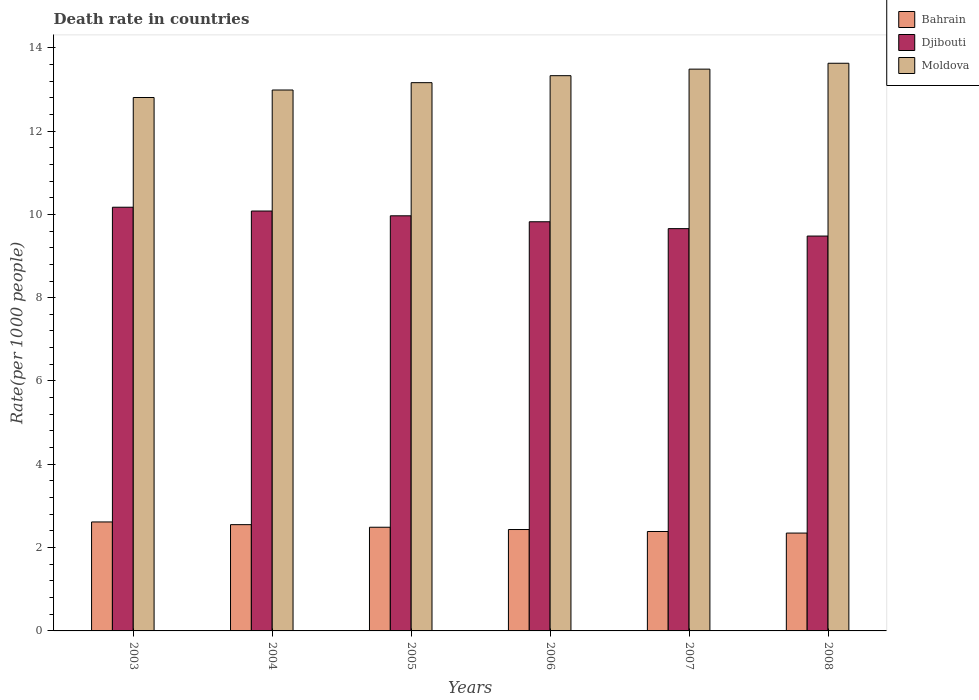How many different coloured bars are there?
Give a very brief answer. 3. How many groups of bars are there?
Offer a terse response. 6. Are the number of bars per tick equal to the number of legend labels?
Provide a succinct answer. Yes. How many bars are there on the 1st tick from the left?
Offer a very short reply. 3. What is the death rate in Moldova in 2003?
Your answer should be compact. 12.8. Across all years, what is the maximum death rate in Bahrain?
Provide a succinct answer. 2.62. Across all years, what is the minimum death rate in Moldova?
Provide a short and direct response. 12.8. In which year was the death rate in Moldova minimum?
Ensure brevity in your answer.  2003. What is the total death rate in Moldova in the graph?
Your answer should be compact. 79.39. What is the difference between the death rate in Djibouti in 2007 and that in 2008?
Offer a terse response. 0.18. What is the difference between the death rate in Moldova in 2008 and the death rate in Bahrain in 2004?
Offer a very short reply. 11.08. What is the average death rate in Moldova per year?
Provide a short and direct response. 13.23. In the year 2003, what is the difference between the death rate in Moldova and death rate in Djibouti?
Offer a very short reply. 2.63. In how many years, is the death rate in Bahrain greater than 10.4?
Provide a short and direct response. 0. What is the ratio of the death rate in Moldova in 2007 to that in 2008?
Give a very brief answer. 0.99. Is the death rate in Moldova in 2006 less than that in 2008?
Give a very brief answer. Yes. What is the difference between the highest and the second highest death rate in Djibouti?
Offer a very short reply. 0.09. What is the difference between the highest and the lowest death rate in Moldova?
Offer a very short reply. 0.82. In how many years, is the death rate in Djibouti greater than the average death rate in Djibouti taken over all years?
Give a very brief answer. 3. Is the sum of the death rate in Djibouti in 2007 and 2008 greater than the maximum death rate in Bahrain across all years?
Your answer should be very brief. Yes. What does the 3rd bar from the left in 2004 represents?
Offer a very short reply. Moldova. What does the 2nd bar from the right in 2007 represents?
Offer a terse response. Djibouti. Is it the case that in every year, the sum of the death rate in Moldova and death rate in Djibouti is greater than the death rate in Bahrain?
Make the answer very short. Yes. How many bars are there?
Make the answer very short. 18. How many years are there in the graph?
Provide a short and direct response. 6. What is the difference between two consecutive major ticks on the Y-axis?
Your answer should be very brief. 2. Are the values on the major ticks of Y-axis written in scientific E-notation?
Give a very brief answer. No. Where does the legend appear in the graph?
Make the answer very short. Top right. How are the legend labels stacked?
Ensure brevity in your answer.  Vertical. What is the title of the graph?
Offer a very short reply. Death rate in countries. What is the label or title of the X-axis?
Offer a terse response. Years. What is the label or title of the Y-axis?
Keep it short and to the point. Rate(per 1000 people). What is the Rate(per 1000 people) of Bahrain in 2003?
Your response must be concise. 2.62. What is the Rate(per 1000 people) of Djibouti in 2003?
Your answer should be very brief. 10.17. What is the Rate(per 1000 people) of Moldova in 2003?
Ensure brevity in your answer.  12.8. What is the Rate(per 1000 people) of Bahrain in 2004?
Your answer should be very brief. 2.55. What is the Rate(per 1000 people) in Djibouti in 2004?
Make the answer very short. 10.08. What is the Rate(per 1000 people) in Moldova in 2004?
Your response must be concise. 12.98. What is the Rate(per 1000 people) of Bahrain in 2005?
Offer a terse response. 2.49. What is the Rate(per 1000 people) of Djibouti in 2005?
Your answer should be very brief. 9.96. What is the Rate(per 1000 people) of Moldova in 2005?
Ensure brevity in your answer.  13.16. What is the Rate(per 1000 people) of Bahrain in 2006?
Ensure brevity in your answer.  2.43. What is the Rate(per 1000 people) of Djibouti in 2006?
Make the answer very short. 9.82. What is the Rate(per 1000 people) in Moldova in 2006?
Provide a short and direct response. 13.33. What is the Rate(per 1000 people) in Bahrain in 2007?
Your answer should be very brief. 2.39. What is the Rate(per 1000 people) in Djibouti in 2007?
Provide a short and direct response. 9.66. What is the Rate(per 1000 people) in Moldova in 2007?
Provide a short and direct response. 13.49. What is the Rate(per 1000 people) in Bahrain in 2008?
Your response must be concise. 2.35. What is the Rate(per 1000 people) of Djibouti in 2008?
Provide a short and direct response. 9.48. What is the Rate(per 1000 people) of Moldova in 2008?
Offer a very short reply. 13.63. Across all years, what is the maximum Rate(per 1000 people) of Bahrain?
Your answer should be very brief. 2.62. Across all years, what is the maximum Rate(per 1000 people) in Djibouti?
Your answer should be very brief. 10.17. Across all years, what is the maximum Rate(per 1000 people) of Moldova?
Provide a short and direct response. 13.63. Across all years, what is the minimum Rate(per 1000 people) of Bahrain?
Offer a terse response. 2.35. Across all years, what is the minimum Rate(per 1000 people) in Djibouti?
Your response must be concise. 9.48. Across all years, what is the minimum Rate(per 1000 people) in Moldova?
Provide a succinct answer. 12.8. What is the total Rate(per 1000 people) of Bahrain in the graph?
Give a very brief answer. 14.83. What is the total Rate(per 1000 people) of Djibouti in the graph?
Keep it short and to the point. 59.17. What is the total Rate(per 1000 people) in Moldova in the graph?
Provide a succinct answer. 79.39. What is the difference between the Rate(per 1000 people) in Bahrain in 2003 and that in 2004?
Your answer should be very brief. 0.07. What is the difference between the Rate(per 1000 people) of Djibouti in 2003 and that in 2004?
Your answer should be very brief. 0.09. What is the difference between the Rate(per 1000 people) in Moldova in 2003 and that in 2004?
Your answer should be compact. -0.18. What is the difference between the Rate(per 1000 people) of Bahrain in 2003 and that in 2005?
Ensure brevity in your answer.  0.13. What is the difference between the Rate(per 1000 people) in Djibouti in 2003 and that in 2005?
Provide a short and direct response. 0.21. What is the difference between the Rate(per 1000 people) of Moldova in 2003 and that in 2005?
Keep it short and to the point. -0.36. What is the difference between the Rate(per 1000 people) of Bahrain in 2003 and that in 2006?
Make the answer very short. 0.18. What is the difference between the Rate(per 1000 people) of Djibouti in 2003 and that in 2006?
Make the answer very short. 0.35. What is the difference between the Rate(per 1000 people) in Moldova in 2003 and that in 2006?
Your response must be concise. -0.52. What is the difference between the Rate(per 1000 people) of Bahrain in 2003 and that in 2007?
Provide a short and direct response. 0.23. What is the difference between the Rate(per 1000 people) of Djibouti in 2003 and that in 2007?
Ensure brevity in your answer.  0.51. What is the difference between the Rate(per 1000 people) in Moldova in 2003 and that in 2007?
Offer a terse response. -0.68. What is the difference between the Rate(per 1000 people) in Bahrain in 2003 and that in 2008?
Your response must be concise. 0.27. What is the difference between the Rate(per 1000 people) in Djibouti in 2003 and that in 2008?
Make the answer very short. 0.69. What is the difference between the Rate(per 1000 people) of Moldova in 2003 and that in 2008?
Your answer should be very brief. -0.82. What is the difference between the Rate(per 1000 people) in Bahrain in 2004 and that in 2005?
Your response must be concise. 0.06. What is the difference between the Rate(per 1000 people) in Djibouti in 2004 and that in 2005?
Keep it short and to the point. 0.12. What is the difference between the Rate(per 1000 people) of Moldova in 2004 and that in 2005?
Give a very brief answer. -0.18. What is the difference between the Rate(per 1000 people) of Bahrain in 2004 and that in 2006?
Ensure brevity in your answer.  0.12. What is the difference between the Rate(per 1000 people) in Djibouti in 2004 and that in 2006?
Ensure brevity in your answer.  0.26. What is the difference between the Rate(per 1000 people) of Moldova in 2004 and that in 2006?
Ensure brevity in your answer.  -0.34. What is the difference between the Rate(per 1000 people) in Bahrain in 2004 and that in 2007?
Offer a terse response. 0.16. What is the difference between the Rate(per 1000 people) in Djibouti in 2004 and that in 2007?
Your answer should be very brief. 0.42. What is the difference between the Rate(per 1000 people) in Moldova in 2004 and that in 2007?
Ensure brevity in your answer.  -0.5. What is the difference between the Rate(per 1000 people) of Bahrain in 2004 and that in 2008?
Your response must be concise. 0.2. What is the difference between the Rate(per 1000 people) of Djibouti in 2004 and that in 2008?
Your answer should be very brief. 0.6. What is the difference between the Rate(per 1000 people) in Moldova in 2004 and that in 2008?
Give a very brief answer. -0.64. What is the difference between the Rate(per 1000 people) of Bahrain in 2005 and that in 2006?
Offer a terse response. 0.06. What is the difference between the Rate(per 1000 people) of Djibouti in 2005 and that in 2006?
Offer a terse response. 0.14. What is the difference between the Rate(per 1000 people) of Moldova in 2005 and that in 2006?
Ensure brevity in your answer.  -0.17. What is the difference between the Rate(per 1000 people) of Bahrain in 2005 and that in 2007?
Provide a succinct answer. 0.1. What is the difference between the Rate(per 1000 people) of Djibouti in 2005 and that in 2007?
Your response must be concise. 0.31. What is the difference between the Rate(per 1000 people) in Moldova in 2005 and that in 2007?
Offer a very short reply. -0.33. What is the difference between the Rate(per 1000 people) of Bahrain in 2005 and that in 2008?
Give a very brief answer. 0.14. What is the difference between the Rate(per 1000 people) of Djibouti in 2005 and that in 2008?
Give a very brief answer. 0.49. What is the difference between the Rate(per 1000 people) in Moldova in 2005 and that in 2008?
Your answer should be compact. -0.47. What is the difference between the Rate(per 1000 people) in Bahrain in 2006 and that in 2007?
Your answer should be very brief. 0.05. What is the difference between the Rate(per 1000 people) in Djibouti in 2006 and that in 2007?
Your answer should be very brief. 0.17. What is the difference between the Rate(per 1000 people) in Moldova in 2006 and that in 2007?
Give a very brief answer. -0.16. What is the difference between the Rate(per 1000 people) of Bahrain in 2006 and that in 2008?
Offer a terse response. 0.09. What is the difference between the Rate(per 1000 people) of Djibouti in 2006 and that in 2008?
Give a very brief answer. 0.34. What is the difference between the Rate(per 1000 people) in Moldova in 2006 and that in 2008?
Your answer should be very brief. -0.3. What is the difference between the Rate(per 1000 people) in Bahrain in 2007 and that in 2008?
Keep it short and to the point. 0.04. What is the difference between the Rate(per 1000 people) in Djibouti in 2007 and that in 2008?
Ensure brevity in your answer.  0.18. What is the difference between the Rate(per 1000 people) in Moldova in 2007 and that in 2008?
Make the answer very short. -0.14. What is the difference between the Rate(per 1000 people) in Bahrain in 2003 and the Rate(per 1000 people) in Djibouti in 2004?
Ensure brevity in your answer.  -7.46. What is the difference between the Rate(per 1000 people) of Bahrain in 2003 and the Rate(per 1000 people) of Moldova in 2004?
Your answer should be compact. -10.37. What is the difference between the Rate(per 1000 people) of Djibouti in 2003 and the Rate(per 1000 people) of Moldova in 2004?
Your answer should be compact. -2.81. What is the difference between the Rate(per 1000 people) of Bahrain in 2003 and the Rate(per 1000 people) of Djibouti in 2005?
Your response must be concise. -7.35. What is the difference between the Rate(per 1000 people) of Bahrain in 2003 and the Rate(per 1000 people) of Moldova in 2005?
Offer a very short reply. -10.54. What is the difference between the Rate(per 1000 people) of Djibouti in 2003 and the Rate(per 1000 people) of Moldova in 2005?
Ensure brevity in your answer.  -2.99. What is the difference between the Rate(per 1000 people) in Bahrain in 2003 and the Rate(per 1000 people) in Djibouti in 2006?
Provide a succinct answer. -7.21. What is the difference between the Rate(per 1000 people) of Bahrain in 2003 and the Rate(per 1000 people) of Moldova in 2006?
Provide a short and direct response. -10.71. What is the difference between the Rate(per 1000 people) of Djibouti in 2003 and the Rate(per 1000 people) of Moldova in 2006?
Make the answer very short. -3.16. What is the difference between the Rate(per 1000 people) of Bahrain in 2003 and the Rate(per 1000 people) of Djibouti in 2007?
Your answer should be compact. -7.04. What is the difference between the Rate(per 1000 people) in Bahrain in 2003 and the Rate(per 1000 people) in Moldova in 2007?
Your response must be concise. -10.87. What is the difference between the Rate(per 1000 people) of Djibouti in 2003 and the Rate(per 1000 people) of Moldova in 2007?
Keep it short and to the point. -3.31. What is the difference between the Rate(per 1000 people) in Bahrain in 2003 and the Rate(per 1000 people) in Djibouti in 2008?
Your answer should be compact. -6.86. What is the difference between the Rate(per 1000 people) of Bahrain in 2003 and the Rate(per 1000 people) of Moldova in 2008?
Ensure brevity in your answer.  -11.01. What is the difference between the Rate(per 1000 people) of Djibouti in 2003 and the Rate(per 1000 people) of Moldova in 2008?
Keep it short and to the point. -3.46. What is the difference between the Rate(per 1000 people) of Bahrain in 2004 and the Rate(per 1000 people) of Djibouti in 2005?
Offer a very short reply. -7.41. What is the difference between the Rate(per 1000 people) in Bahrain in 2004 and the Rate(per 1000 people) in Moldova in 2005?
Give a very brief answer. -10.61. What is the difference between the Rate(per 1000 people) in Djibouti in 2004 and the Rate(per 1000 people) in Moldova in 2005?
Your response must be concise. -3.08. What is the difference between the Rate(per 1000 people) in Bahrain in 2004 and the Rate(per 1000 people) in Djibouti in 2006?
Offer a very short reply. -7.27. What is the difference between the Rate(per 1000 people) in Bahrain in 2004 and the Rate(per 1000 people) in Moldova in 2006?
Offer a terse response. -10.78. What is the difference between the Rate(per 1000 people) of Djibouti in 2004 and the Rate(per 1000 people) of Moldova in 2006?
Your response must be concise. -3.25. What is the difference between the Rate(per 1000 people) of Bahrain in 2004 and the Rate(per 1000 people) of Djibouti in 2007?
Offer a very short reply. -7.11. What is the difference between the Rate(per 1000 people) of Bahrain in 2004 and the Rate(per 1000 people) of Moldova in 2007?
Make the answer very short. -10.94. What is the difference between the Rate(per 1000 people) in Djibouti in 2004 and the Rate(per 1000 people) in Moldova in 2007?
Your answer should be compact. -3.41. What is the difference between the Rate(per 1000 people) in Bahrain in 2004 and the Rate(per 1000 people) in Djibouti in 2008?
Your answer should be very brief. -6.93. What is the difference between the Rate(per 1000 people) in Bahrain in 2004 and the Rate(per 1000 people) in Moldova in 2008?
Your answer should be compact. -11.08. What is the difference between the Rate(per 1000 people) in Djibouti in 2004 and the Rate(per 1000 people) in Moldova in 2008?
Provide a succinct answer. -3.55. What is the difference between the Rate(per 1000 people) in Bahrain in 2005 and the Rate(per 1000 people) in Djibouti in 2006?
Keep it short and to the point. -7.33. What is the difference between the Rate(per 1000 people) in Bahrain in 2005 and the Rate(per 1000 people) in Moldova in 2006?
Keep it short and to the point. -10.84. What is the difference between the Rate(per 1000 people) of Djibouti in 2005 and the Rate(per 1000 people) of Moldova in 2006?
Your answer should be compact. -3.36. What is the difference between the Rate(per 1000 people) of Bahrain in 2005 and the Rate(per 1000 people) of Djibouti in 2007?
Give a very brief answer. -7.17. What is the difference between the Rate(per 1000 people) of Bahrain in 2005 and the Rate(per 1000 people) of Moldova in 2007?
Provide a succinct answer. -11. What is the difference between the Rate(per 1000 people) in Djibouti in 2005 and the Rate(per 1000 people) in Moldova in 2007?
Your answer should be very brief. -3.52. What is the difference between the Rate(per 1000 people) of Bahrain in 2005 and the Rate(per 1000 people) of Djibouti in 2008?
Keep it short and to the point. -6.99. What is the difference between the Rate(per 1000 people) in Bahrain in 2005 and the Rate(per 1000 people) in Moldova in 2008?
Your response must be concise. -11.14. What is the difference between the Rate(per 1000 people) of Djibouti in 2005 and the Rate(per 1000 people) of Moldova in 2008?
Provide a succinct answer. -3.66. What is the difference between the Rate(per 1000 people) in Bahrain in 2006 and the Rate(per 1000 people) in Djibouti in 2007?
Give a very brief answer. -7.22. What is the difference between the Rate(per 1000 people) of Bahrain in 2006 and the Rate(per 1000 people) of Moldova in 2007?
Provide a short and direct response. -11.05. What is the difference between the Rate(per 1000 people) of Djibouti in 2006 and the Rate(per 1000 people) of Moldova in 2007?
Provide a succinct answer. -3.66. What is the difference between the Rate(per 1000 people) in Bahrain in 2006 and the Rate(per 1000 people) in Djibouti in 2008?
Your answer should be very brief. -7.04. What is the difference between the Rate(per 1000 people) in Bahrain in 2006 and the Rate(per 1000 people) in Moldova in 2008?
Offer a terse response. -11.19. What is the difference between the Rate(per 1000 people) of Djibouti in 2006 and the Rate(per 1000 people) of Moldova in 2008?
Ensure brevity in your answer.  -3.81. What is the difference between the Rate(per 1000 people) in Bahrain in 2007 and the Rate(per 1000 people) in Djibouti in 2008?
Offer a terse response. -7.09. What is the difference between the Rate(per 1000 people) in Bahrain in 2007 and the Rate(per 1000 people) in Moldova in 2008?
Provide a short and direct response. -11.24. What is the difference between the Rate(per 1000 people) of Djibouti in 2007 and the Rate(per 1000 people) of Moldova in 2008?
Give a very brief answer. -3.97. What is the average Rate(per 1000 people) of Bahrain per year?
Provide a succinct answer. 2.47. What is the average Rate(per 1000 people) of Djibouti per year?
Give a very brief answer. 9.86. What is the average Rate(per 1000 people) of Moldova per year?
Give a very brief answer. 13.23. In the year 2003, what is the difference between the Rate(per 1000 people) of Bahrain and Rate(per 1000 people) of Djibouti?
Your answer should be very brief. -7.55. In the year 2003, what is the difference between the Rate(per 1000 people) in Bahrain and Rate(per 1000 people) in Moldova?
Your answer should be very brief. -10.19. In the year 2003, what is the difference between the Rate(per 1000 people) in Djibouti and Rate(per 1000 people) in Moldova?
Your response must be concise. -2.63. In the year 2004, what is the difference between the Rate(per 1000 people) in Bahrain and Rate(per 1000 people) in Djibouti?
Offer a very short reply. -7.53. In the year 2004, what is the difference between the Rate(per 1000 people) of Bahrain and Rate(per 1000 people) of Moldova?
Offer a terse response. -10.43. In the year 2004, what is the difference between the Rate(per 1000 people) of Djibouti and Rate(per 1000 people) of Moldova?
Provide a short and direct response. -2.9. In the year 2005, what is the difference between the Rate(per 1000 people) of Bahrain and Rate(per 1000 people) of Djibouti?
Offer a terse response. -7.48. In the year 2005, what is the difference between the Rate(per 1000 people) of Bahrain and Rate(per 1000 people) of Moldova?
Give a very brief answer. -10.67. In the year 2005, what is the difference between the Rate(per 1000 people) in Djibouti and Rate(per 1000 people) in Moldova?
Your response must be concise. -3.2. In the year 2006, what is the difference between the Rate(per 1000 people) in Bahrain and Rate(per 1000 people) in Djibouti?
Your answer should be compact. -7.39. In the year 2006, what is the difference between the Rate(per 1000 people) of Bahrain and Rate(per 1000 people) of Moldova?
Provide a short and direct response. -10.89. In the year 2006, what is the difference between the Rate(per 1000 people) of Djibouti and Rate(per 1000 people) of Moldova?
Offer a very short reply. -3.51. In the year 2007, what is the difference between the Rate(per 1000 people) of Bahrain and Rate(per 1000 people) of Djibouti?
Ensure brevity in your answer.  -7.27. In the year 2007, what is the difference between the Rate(per 1000 people) in Bahrain and Rate(per 1000 people) in Moldova?
Ensure brevity in your answer.  -11.1. In the year 2007, what is the difference between the Rate(per 1000 people) in Djibouti and Rate(per 1000 people) in Moldova?
Ensure brevity in your answer.  -3.83. In the year 2008, what is the difference between the Rate(per 1000 people) of Bahrain and Rate(per 1000 people) of Djibouti?
Your answer should be very brief. -7.13. In the year 2008, what is the difference between the Rate(per 1000 people) of Bahrain and Rate(per 1000 people) of Moldova?
Keep it short and to the point. -11.28. In the year 2008, what is the difference between the Rate(per 1000 people) of Djibouti and Rate(per 1000 people) of Moldova?
Ensure brevity in your answer.  -4.15. What is the ratio of the Rate(per 1000 people) of Bahrain in 2003 to that in 2004?
Make the answer very short. 1.03. What is the ratio of the Rate(per 1000 people) in Moldova in 2003 to that in 2004?
Your answer should be compact. 0.99. What is the ratio of the Rate(per 1000 people) of Bahrain in 2003 to that in 2005?
Your answer should be compact. 1.05. What is the ratio of the Rate(per 1000 people) in Djibouti in 2003 to that in 2005?
Your answer should be compact. 1.02. What is the ratio of the Rate(per 1000 people) of Moldova in 2003 to that in 2005?
Make the answer very short. 0.97. What is the ratio of the Rate(per 1000 people) in Bahrain in 2003 to that in 2006?
Give a very brief answer. 1.07. What is the ratio of the Rate(per 1000 people) of Djibouti in 2003 to that in 2006?
Your response must be concise. 1.04. What is the ratio of the Rate(per 1000 people) in Moldova in 2003 to that in 2006?
Provide a short and direct response. 0.96. What is the ratio of the Rate(per 1000 people) in Bahrain in 2003 to that in 2007?
Provide a succinct answer. 1.1. What is the ratio of the Rate(per 1000 people) in Djibouti in 2003 to that in 2007?
Your response must be concise. 1.05. What is the ratio of the Rate(per 1000 people) of Moldova in 2003 to that in 2007?
Provide a short and direct response. 0.95. What is the ratio of the Rate(per 1000 people) in Bahrain in 2003 to that in 2008?
Your response must be concise. 1.11. What is the ratio of the Rate(per 1000 people) in Djibouti in 2003 to that in 2008?
Your response must be concise. 1.07. What is the ratio of the Rate(per 1000 people) of Moldova in 2003 to that in 2008?
Make the answer very short. 0.94. What is the ratio of the Rate(per 1000 people) of Bahrain in 2004 to that in 2005?
Give a very brief answer. 1.02. What is the ratio of the Rate(per 1000 people) of Djibouti in 2004 to that in 2005?
Offer a very short reply. 1.01. What is the ratio of the Rate(per 1000 people) of Moldova in 2004 to that in 2005?
Provide a succinct answer. 0.99. What is the ratio of the Rate(per 1000 people) of Bahrain in 2004 to that in 2006?
Ensure brevity in your answer.  1.05. What is the ratio of the Rate(per 1000 people) of Djibouti in 2004 to that in 2006?
Offer a very short reply. 1.03. What is the ratio of the Rate(per 1000 people) in Moldova in 2004 to that in 2006?
Offer a terse response. 0.97. What is the ratio of the Rate(per 1000 people) of Bahrain in 2004 to that in 2007?
Your answer should be compact. 1.07. What is the ratio of the Rate(per 1000 people) in Djibouti in 2004 to that in 2007?
Make the answer very short. 1.04. What is the ratio of the Rate(per 1000 people) of Moldova in 2004 to that in 2007?
Your answer should be compact. 0.96. What is the ratio of the Rate(per 1000 people) in Bahrain in 2004 to that in 2008?
Offer a very short reply. 1.09. What is the ratio of the Rate(per 1000 people) in Djibouti in 2004 to that in 2008?
Your answer should be very brief. 1.06. What is the ratio of the Rate(per 1000 people) in Moldova in 2004 to that in 2008?
Provide a succinct answer. 0.95. What is the ratio of the Rate(per 1000 people) in Bahrain in 2005 to that in 2006?
Keep it short and to the point. 1.02. What is the ratio of the Rate(per 1000 people) in Djibouti in 2005 to that in 2006?
Keep it short and to the point. 1.01. What is the ratio of the Rate(per 1000 people) in Moldova in 2005 to that in 2006?
Ensure brevity in your answer.  0.99. What is the ratio of the Rate(per 1000 people) in Bahrain in 2005 to that in 2007?
Ensure brevity in your answer.  1.04. What is the ratio of the Rate(per 1000 people) of Djibouti in 2005 to that in 2007?
Make the answer very short. 1.03. What is the ratio of the Rate(per 1000 people) in Moldova in 2005 to that in 2007?
Make the answer very short. 0.98. What is the ratio of the Rate(per 1000 people) in Bahrain in 2005 to that in 2008?
Offer a terse response. 1.06. What is the ratio of the Rate(per 1000 people) in Djibouti in 2005 to that in 2008?
Offer a terse response. 1.05. What is the ratio of the Rate(per 1000 people) in Moldova in 2005 to that in 2008?
Provide a succinct answer. 0.97. What is the ratio of the Rate(per 1000 people) in Bahrain in 2006 to that in 2007?
Your answer should be very brief. 1.02. What is the ratio of the Rate(per 1000 people) in Djibouti in 2006 to that in 2007?
Your response must be concise. 1.02. What is the ratio of the Rate(per 1000 people) in Moldova in 2006 to that in 2007?
Offer a terse response. 0.99. What is the ratio of the Rate(per 1000 people) of Bahrain in 2006 to that in 2008?
Keep it short and to the point. 1.04. What is the ratio of the Rate(per 1000 people) in Djibouti in 2006 to that in 2008?
Your answer should be very brief. 1.04. What is the ratio of the Rate(per 1000 people) of Moldova in 2006 to that in 2008?
Ensure brevity in your answer.  0.98. What is the ratio of the Rate(per 1000 people) of Bahrain in 2007 to that in 2008?
Provide a short and direct response. 1.02. What is the ratio of the Rate(per 1000 people) of Djibouti in 2007 to that in 2008?
Provide a succinct answer. 1.02. What is the difference between the highest and the second highest Rate(per 1000 people) in Bahrain?
Offer a terse response. 0.07. What is the difference between the highest and the second highest Rate(per 1000 people) of Djibouti?
Provide a short and direct response. 0.09. What is the difference between the highest and the second highest Rate(per 1000 people) in Moldova?
Your response must be concise. 0.14. What is the difference between the highest and the lowest Rate(per 1000 people) in Bahrain?
Provide a succinct answer. 0.27. What is the difference between the highest and the lowest Rate(per 1000 people) in Djibouti?
Provide a short and direct response. 0.69. What is the difference between the highest and the lowest Rate(per 1000 people) in Moldova?
Offer a very short reply. 0.82. 